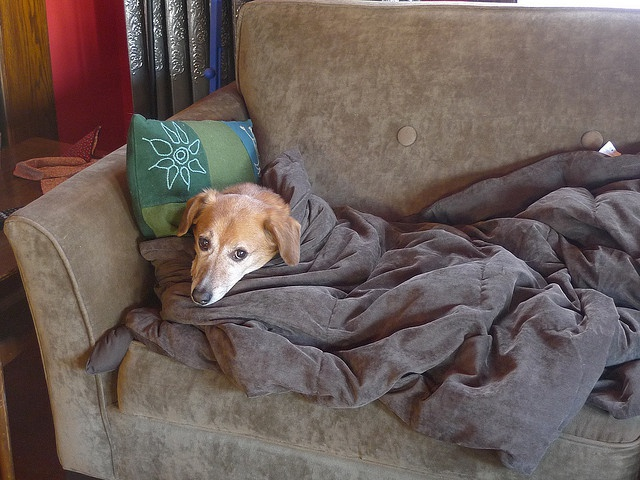Describe the objects in this image and their specific colors. I can see couch in olive and gray tones and dog in olive, tan, lightgray, gray, and darkgray tones in this image. 